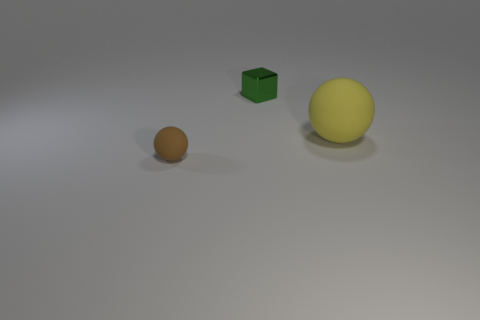Is there a brown ball of the same size as the green metal cube?
Provide a short and direct response. Yes. There is a sphere that is on the left side of the yellow matte thing; is it the same size as the green cube?
Make the answer very short. Yes. Are there more brown matte spheres than spheres?
Keep it short and to the point. No. Are there any other big objects that have the same shape as the large yellow rubber object?
Make the answer very short. No. What is the shape of the matte thing on the right side of the cube?
Your response must be concise. Sphere. There is a small thing that is to the right of the matte object on the left side of the tiny metallic block; what number of matte spheres are to the right of it?
Offer a very short reply. 1. What number of other objects are there of the same shape as the brown object?
Provide a succinct answer. 1. How many other objects are the same material as the large yellow sphere?
Provide a succinct answer. 1. What material is the small thing in front of the matte sphere behind the small thing in front of the small metallic block?
Offer a very short reply. Rubber. Are the large thing and the small green object made of the same material?
Provide a short and direct response. No. 